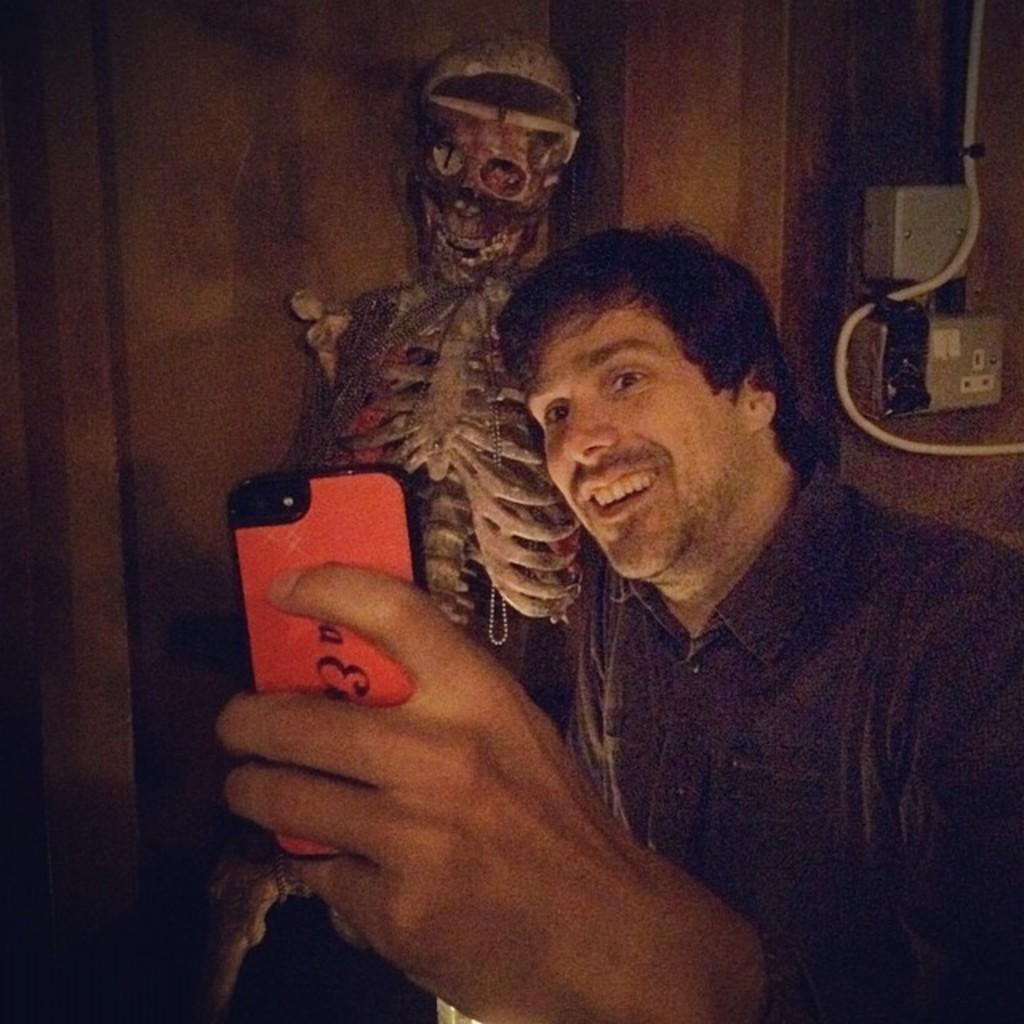What is the person in the image doing? The person is standing in the image. What object is the person holding? The person is holding a mobile. What can be seen in the background of the image? There is a skeleton and power boxes on the wall in the background of the image. How many boys with blue eyes are visible in the image? There is no mention of boys or blue eyes in the image; the facts provided only mention a person, a mobile, a skeleton, and power boxes on the wall. 